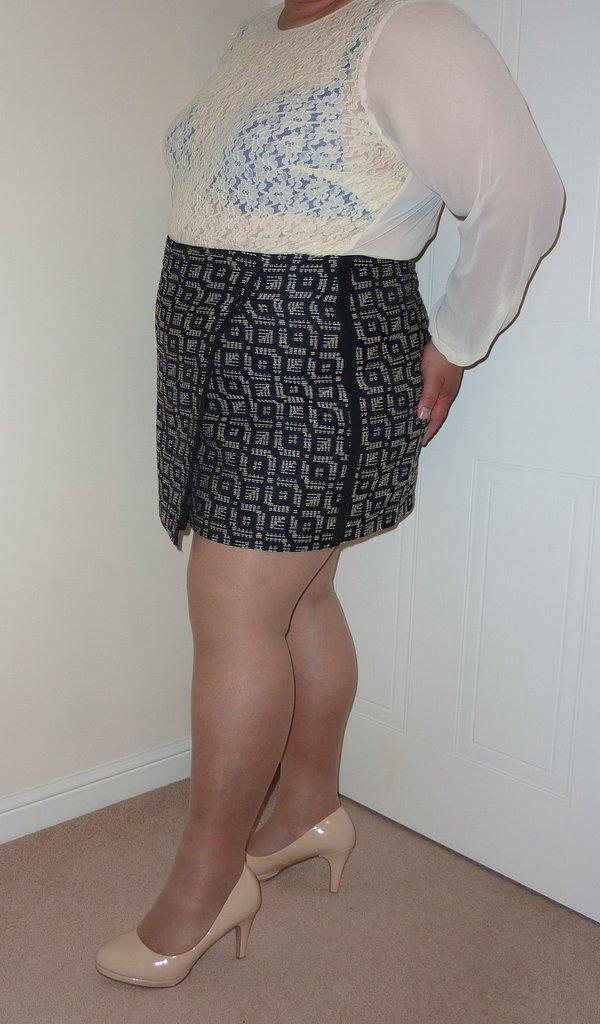Who is the main subject in the image? There is a woman in the image. What type of footwear is the woman wearing? The woman is wearing sandals. What surface is the woman standing on? The woman is standing on the floor. What can be seen behind the woman? There is a door visible behind the woman. What is in the background of the image? There is a wall in the background of the image. How many pizzas are balanced on the woman's head in the image? There are no pizzas present in the image; the woman is not balancing any pizzas on her head. 